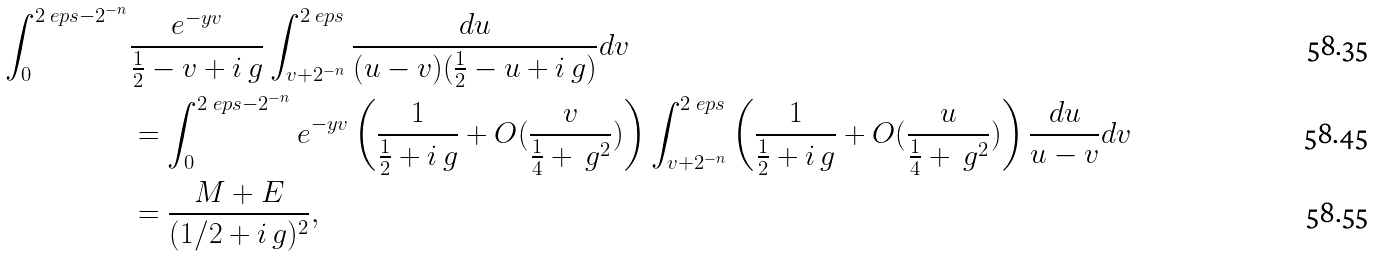<formula> <loc_0><loc_0><loc_500><loc_500>\int _ { 0 } ^ { 2 \ e p s - 2 ^ { - n } } & \frac { e ^ { - y v } } { \frac { 1 } { 2 } - v + i \ g } \int _ { v + 2 ^ { - n } } ^ { 2 \ e p s } \frac { d u } { ( u - v ) ( \frac { 1 } { 2 } - u + i \ g ) } d v \\ & = \int _ { 0 } ^ { 2 \ e p s - 2 ^ { - n } } e ^ { - y v } \left ( \frac { 1 } { \frac { 1 } { 2 } + i \ g } + O ( \frac { v } { \frac { 1 } { 4 } + { \ g } ^ { 2 } } ) \right ) \int _ { v + 2 ^ { - n } } ^ { 2 \ e p s } \left ( \frac { 1 } { \frac { 1 } { 2 } + i \ g } + O ( \frac { u } { \frac { 1 } { 4 } + { \ g } ^ { 2 } } ) \right ) \frac { d u } { u - v } d v \\ & = \frac { M + E } { ( 1 / 2 + i \ g ) ^ { 2 } } ,</formula> 